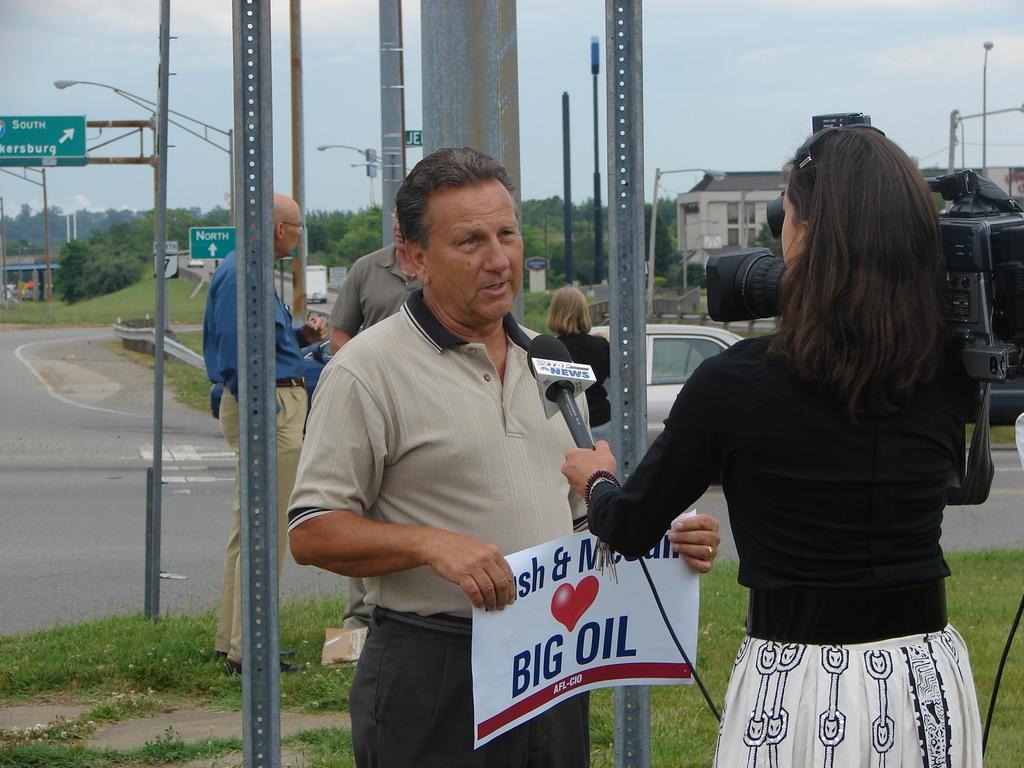How would you summarize this image in a sentence or two? In this picture we can see few people, in the middle of the image we can see a man, he is holding a poster, in front of him we can see a woman and she is holding a microphone, on the right side of the image we can see a camera, in the background we can see few poles, vehicles, sign boards, trees and buildings. 